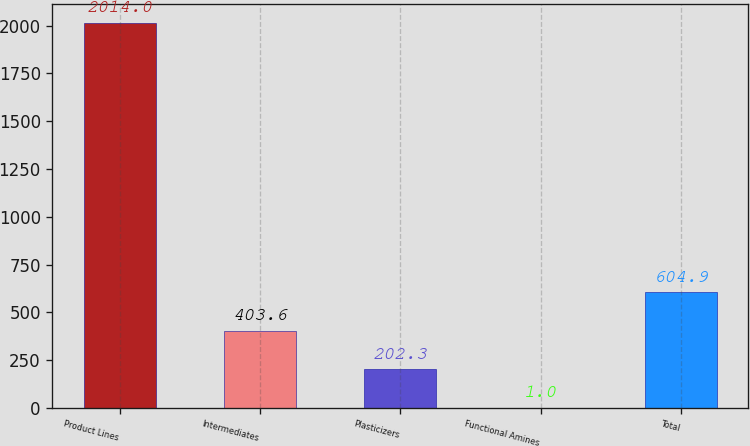<chart> <loc_0><loc_0><loc_500><loc_500><bar_chart><fcel>Product Lines<fcel>Intermediates<fcel>Plasticizers<fcel>Functional Amines<fcel>Total<nl><fcel>2014<fcel>403.6<fcel>202.3<fcel>1<fcel>604.9<nl></chart> 